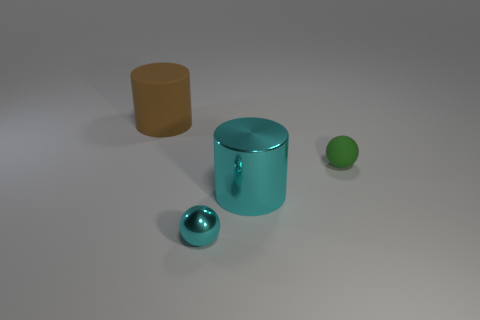Add 3 small metal spheres. How many objects exist? 7 Subtract 0 yellow blocks. How many objects are left? 4 Subtract all tiny blue rubber cylinders. Subtract all tiny matte objects. How many objects are left? 3 Add 1 tiny cyan metal objects. How many tiny cyan metal objects are left? 2 Add 2 green matte cylinders. How many green matte cylinders exist? 2 